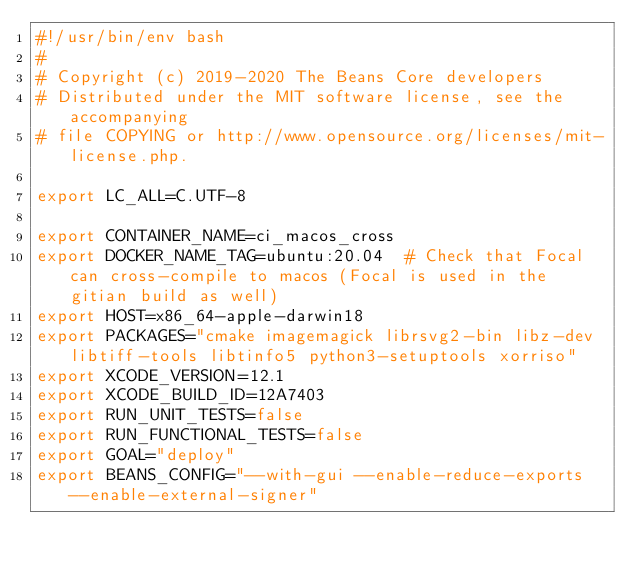Convert code to text. <code><loc_0><loc_0><loc_500><loc_500><_Bash_>#!/usr/bin/env bash
#
# Copyright (c) 2019-2020 The Beans Core developers
# Distributed under the MIT software license, see the accompanying
# file COPYING or http://www.opensource.org/licenses/mit-license.php.

export LC_ALL=C.UTF-8

export CONTAINER_NAME=ci_macos_cross
export DOCKER_NAME_TAG=ubuntu:20.04  # Check that Focal can cross-compile to macos (Focal is used in the gitian build as well)
export HOST=x86_64-apple-darwin18
export PACKAGES="cmake imagemagick librsvg2-bin libz-dev libtiff-tools libtinfo5 python3-setuptools xorriso"
export XCODE_VERSION=12.1
export XCODE_BUILD_ID=12A7403
export RUN_UNIT_TESTS=false
export RUN_FUNCTIONAL_TESTS=false
export GOAL="deploy"
export BEANS_CONFIG="--with-gui --enable-reduce-exports --enable-external-signer"
</code> 